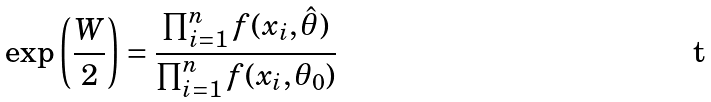<formula> <loc_0><loc_0><loc_500><loc_500>\exp \left ( \frac { W } { 2 } \right ) = \frac { \prod _ { i = 1 } ^ { n } f ( x _ { i } , \hat { \theta } ) } { \prod _ { i = 1 } ^ { n } f ( x _ { i } , \theta _ { 0 } ) }</formula> 